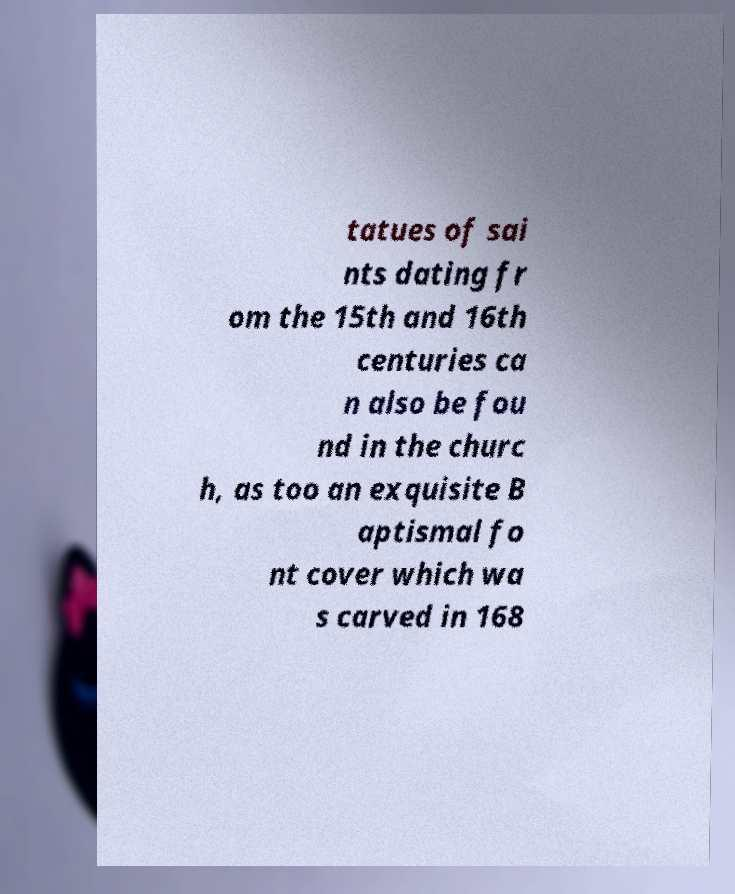Please read and relay the text visible in this image. What does it say? tatues of sai nts dating fr om the 15th and 16th centuries ca n also be fou nd in the churc h, as too an exquisite B aptismal fo nt cover which wa s carved in 168 